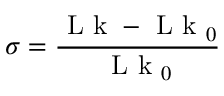Convert formula to latex. <formula><loc_0><loc_0><loc_500><loc_500>\sigma = \frac { L k - L k _ { 0 } } { L k _ { 0 } }</formula> 